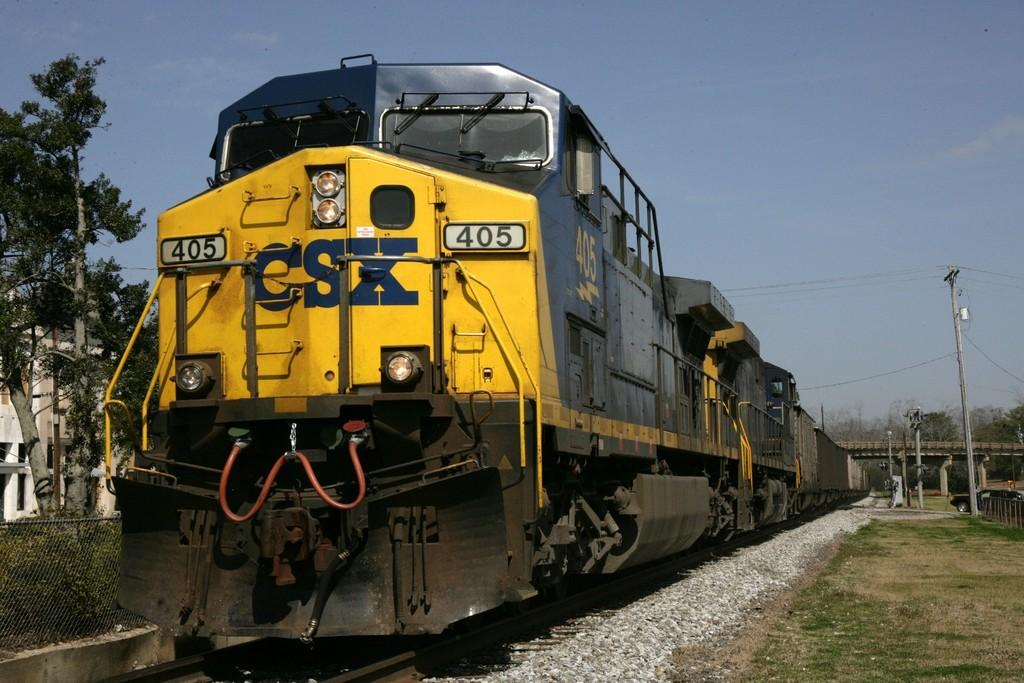What is the main subject of the image? The main subject of the image is a train on the track. What type of terrain can be seen in the image? Stones, grass, and a group of trees are visible in the image, indicating a mix of rocky and natural terrain. What structures are present in the image? Poles, a bridge, and a metal fence are present in the image. What is visible in the sky in the image? The sky is visible in the image, and it looks cloudy. How does the train affect the throat of the person in the image? There is no person present in the image, so it is not possible to determine any effect on a person's throat. --- Facts: 1. There is a person holding a camera in the image. 2. The person is standing on a bridge. 3. There is a river visible in the image. 4. The sky is visible in the image. 5. There are trees on the riverbank. Absurd Topics: parrot, bicycle, sand Conversation: What is the person in the image doing? The person in the image is holding a camera. Where is the person standing in the image? The person is standing on a bridge. What can be seen in the background of the image? There is a river and trees on the riverbank visible in the image. What is visible in the sky in the image? The sky is visible in the image. Reasoning: Let's think step by step in order to produce the conversation. We start by identifying the main subject of the image, which is the person holding a camera. Then, we describe the location of the person, which is on a bridge. Next, we mention the background elements, including the river and trees on the riverbank. Finally, we mention the sky's condition, which is visible in the image. Absurd Question/Answer: What type of sand can be seen on the bicycle in the image? There is no bicycle present in the image, so it is not possible to determine any sand on a bicycle. 